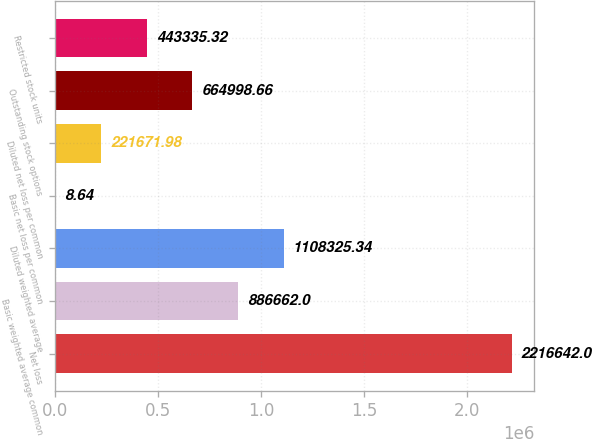Convert chart. <chart><loc_0><loc_0><loc_500><loc_500><bar_chart><fcel>Net loss<fcel>Basic weighted average common<fcel>Diluted weighted average<fcel>Basic net loss per common<fcel>Diluted net loss per common<fcel>Outstanding stock options<fcel>Restricted stock units<nl><fcel>2.21664e+06<fcel>886662<fcel>1.10833e+06<fcel>8.64<fcel>221672<fcel>664999<fcel>443335<nl></chart> 